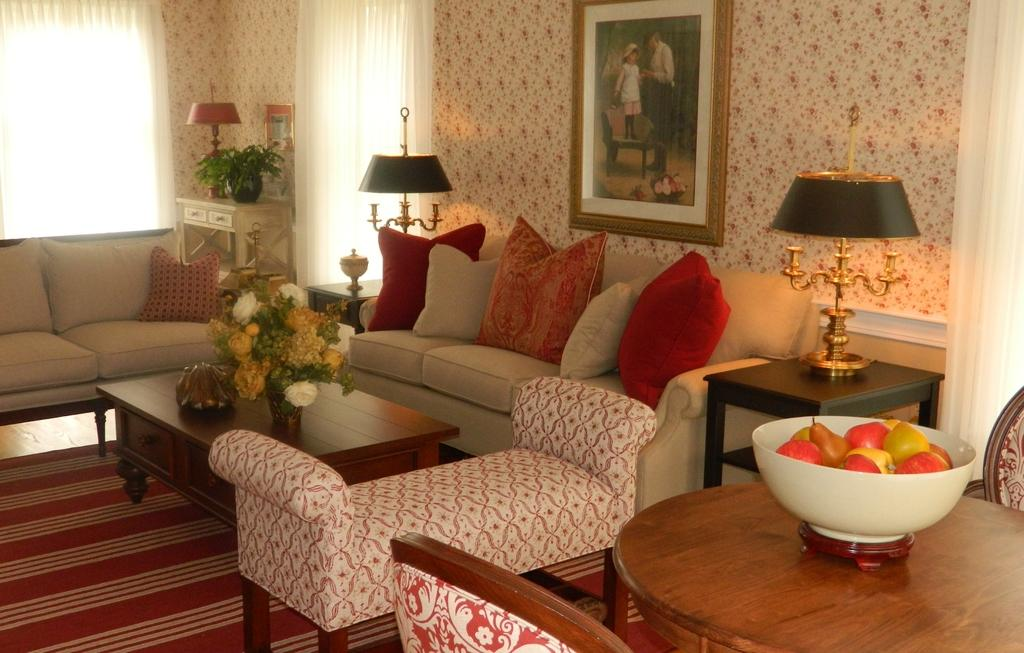What type of furniture is in the image? There is a sofa set in the image. What is on the table in the image? There is a flower vase on a table. What is hanging on the wall in the image? There is a photo frame on the wall. What is in a bowl in the image? There are fruits in a bowl in the image. What type of plant is visible in the image? There is a plant in the image. What type of window treatment is present in the image? There are curtains near a window in the image. How many yaks are visible in the image? There are no yaks present in the image. What type of beam is supporting the ceiling in the image? There is no mention of a beam supporting the ceiling in the image. 